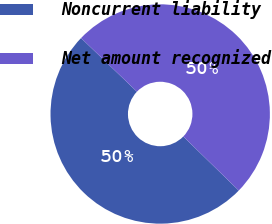<chart> <loc_0><loc_0><loc_500><loc_500><pie_chart><fcel>Noncurrent liability<fcel>Net amount recognized<nl><fcel>49.88%<fcel>50.12%<nl></chart> 